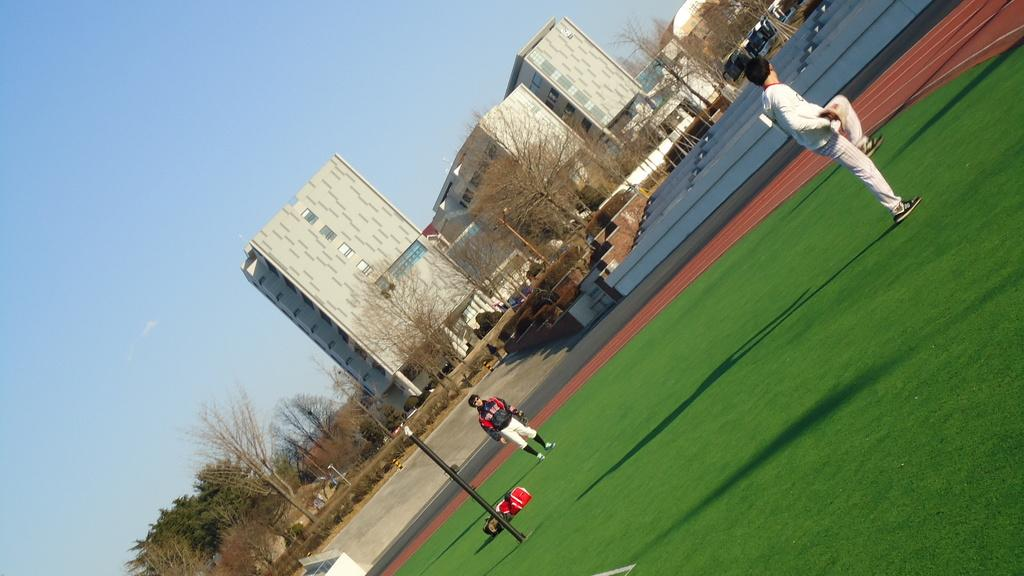What can be seen in the sky in the image? The sky is visible in the image. What type of structures are present in the image? There are buildings in the image. What other natural elements can be seen in the image? Trees are present in the image. What architectural features are visible in the image? Poles and stairs are visible in the image. Are there any people in the image? Yes, there are persons standing on the ground in the image. Can you tell me how many roses are being held by the persons in the image? There are no roses visible in the image; the persons are standing on the ground without any flowers. What type of adjustment can be seen being made to the balloon in the image? There is no balloon present in the image, so no adjustments can be observed. 